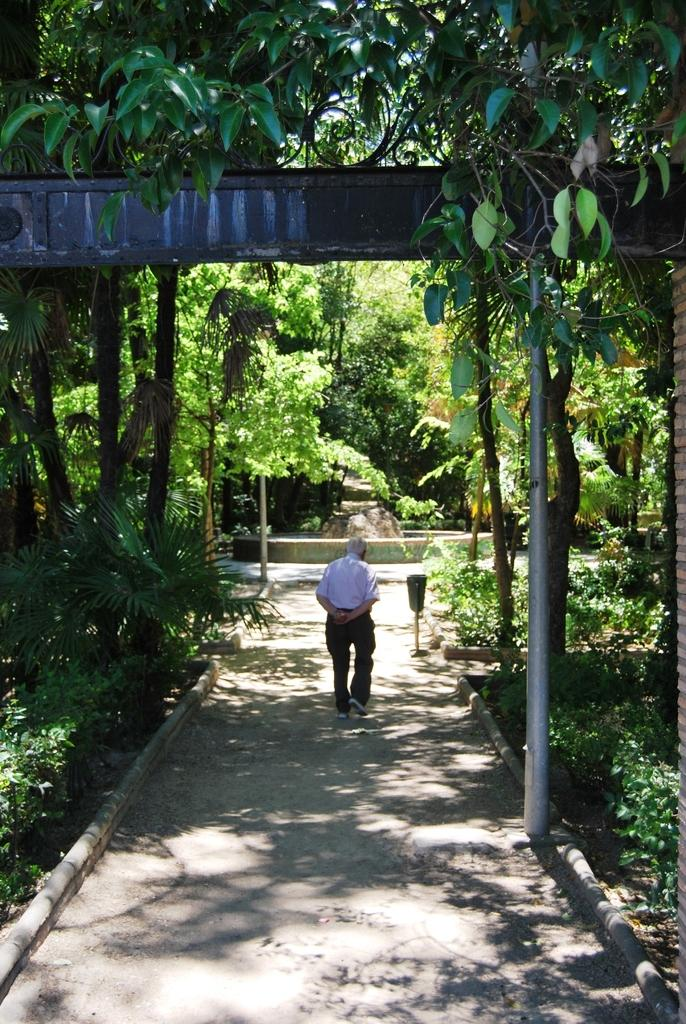What is the man in the image doing? The man is walking in the image. Where is the man walking? The man is walking on a path. What can be seen on both sides of the path? Plants and trees are present on both sides of the path. What is visible in the background of the image? There are trees in the background of the image. What type of apple is the man holding in the image? There is no apple present in the image; the man is simply walking on a path surrounded by plants and trees. 